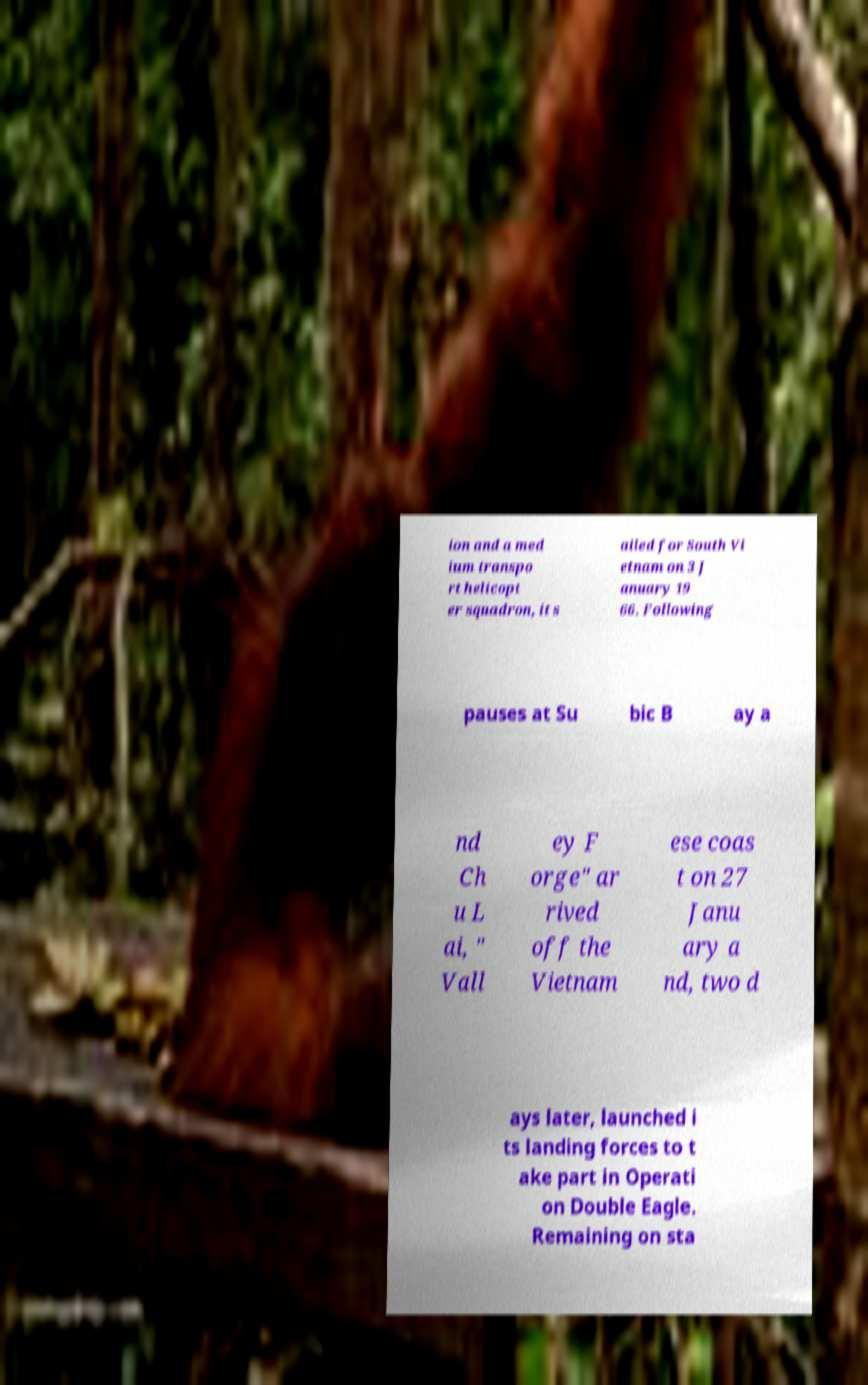What messages or text are displayed in this image? I need them in a readable, typed format. ion and a med ium transpo rt helicopt er squadron, it s ailed for South Vi etnam on 3 J anuary 19 66. Following pauses at Su bic B ay a nd Ch u L ai, " Vall ey F orge" ar rived off the Vietnam ese coas t on 27 Janu ary a nd, two d ays later, launched i ts landing forces to t ake part in Operati on Double Eagle. Remaining on sta 